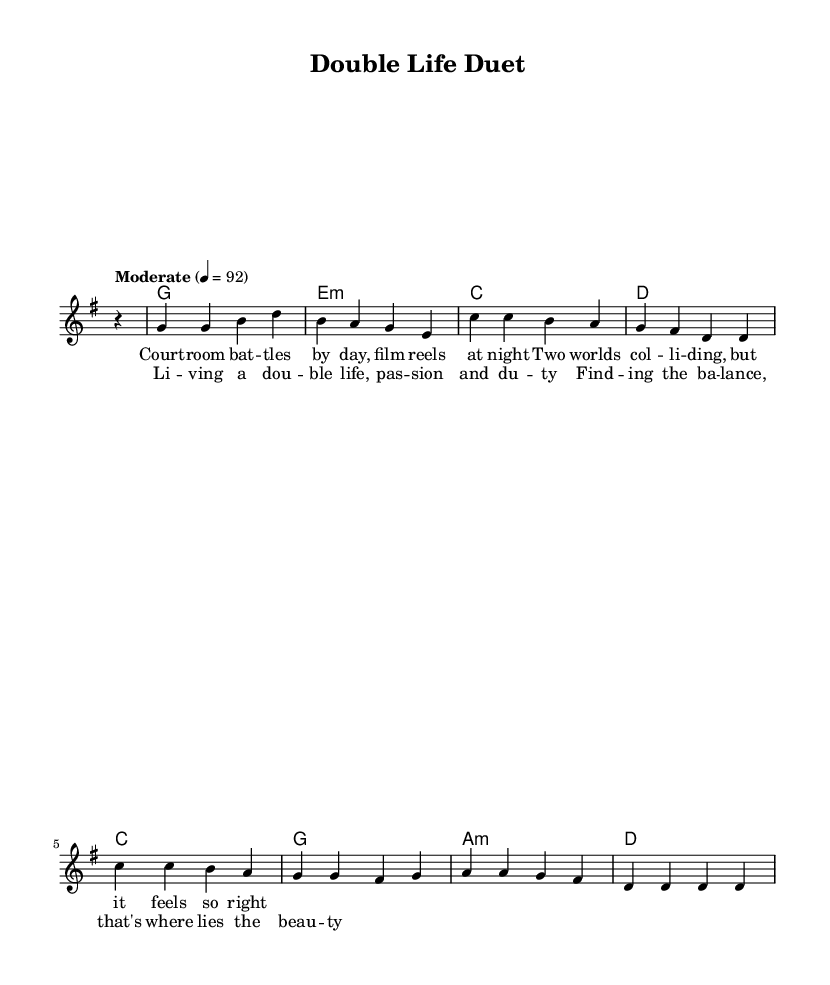What is the key signature of this music? The key signature is G major, which has one sharp. This can be determined by looking at the key signature indicated at the beginning of the score.
Answer: G major What is the time signature of this music? The time signature is 4/4, which can be identified at the beginning of the score. It shows that there are four beats in each measure and the quarter note gets one beat.
Answer: 4/4 What is the tempo marking of this music? The tempo marking is "Moderate" with a metronome indication of 92 beats per minute. This is indicated in the tempo line at the beginning of the piece.
Answer: Moderate, 92 How many measures are in the melody section? The melody section spans 8 measures, as indicated by counting the measure lines in the melody part of the score.
Answer: 8 What is the harmonic progression used in the chorus? The harmonic progression used in the chorus follows G, E minor, C, and D, which can be seen clearly in the chord symbols written above the lyrics in the chorus section.
Answer: G, E minor, C, D What is the theme of the song? The theme reflects the balance between professional life and personal passions, as suggested by the lyrics discussing "courtroom battles by day" and "film reels at night." This explores the duality of life experiences.
Answer: Balance between work and passion What chord is used in the first measure of the harmony? The first measure of the harmony features the G major chord, identifiable by the chord symbol written above the corresponding melody notes.
Answer: G 